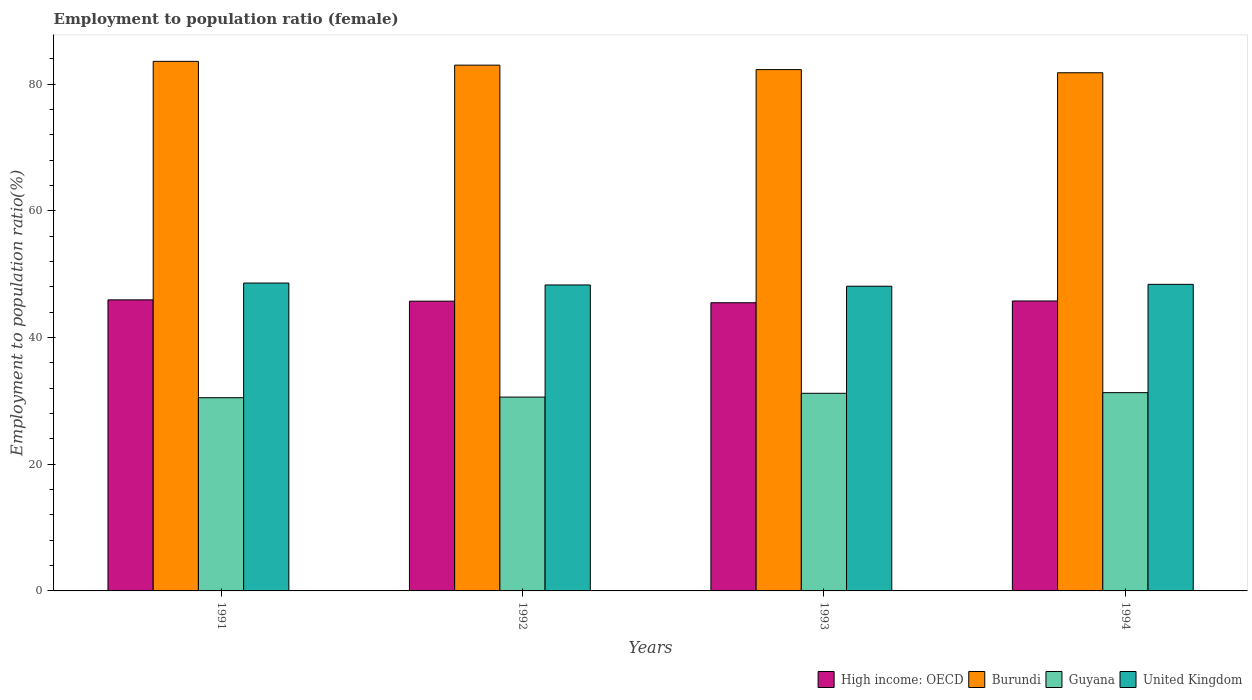How many different coloured bars are there?
Give a very brief answer. 4. Are the number of bars on each tick of the X-axis equal?
Provide a short and direct response. Yes. How many bars are there on the 3rd tick from the right?
Offer a very short reply. 4. What is the label of the 4th group of bars from the left?
Offer a very short reply. 1994. What is the employment to population ratio in High income: OECD in 1994?
Offer a terse response. 45.77. Across all years, what is the maximum employment to population ratio in United Kingdom?
Make the answer very short. 48.6. Across all years, what is the minimum employment to population ratio in Guyana?
Offer a terse response. 30.5. In which year was the employment to population ratio in Guyana minimum?
Offer a terse response. 1991. What is the total employment to population ratio in High income: OECD in the graph?
Make the answer very short. 182.95. What is the difference between the employment to population ratio in United Kingdom in 1993 and that in 1994?
Provide a succinct answer. -0.3. What is the difference between the employment to population ratio in Burundi in 1992 and the employment to population ratio in High income: OECD in 1993?
Offer a terse response. 37.51. What is the average employment to population ratio in Guyana per year?
Your response must be concise. 30.9. In the year 1992, what is the difference between the employment to population ratio in High income: OECD and employment to population ratio in Burundi?
Ensure brevity in your answer.  -37.26. In how many years, is the employment to population ratio in High income: OECD greater than 28 %?
Your response must be concise. 4. What is the ratio of the employment to population ratio in Burundi in 1992 to that in 1994?
Your answer should be compact. 1.01. Is the employment to population ratio in High income: OECD in 1991 less than that in 1993?
Your response must be concise. No. What is the difference between the highest and the second highest employment to population ratio in Burundi?
Offer a terse response. 0.6. What is the difference between the highest and the lowest employment to population ratio in High income: OECD?
Give a very brief answer. 0.45. In how many years, is the employment to population ratio in United Kingdom greater than the average employment to population ratio in United Kingdom taken over all years?
Make the answer very short. 2. What does the 1st bar from the left in 1993 represents?
Your response must be concise. High income: OECD. What does the 4th bar from the right in 1994 represents?
Make the answer very short. High income: OECD. Is it the case that in every year, the sum of the employment to population ratio in United Kingdom and employment to population ratio in Guyana is greater than the employment to population ratio in Burundi?
Make the answer very short. No. Are all the bars in the graph horizontal?
Provide a short and direct response. No. How many years are there in the graph?
Keep it short and to the point. 4. What is the difference between two consecutive major ticks on the Y-axis?
Give a very brief answer. 20. Are the values on the major ticks of Y-axis written in scientific E-notation?
Make the answer very short. No. How are the legend labels stacked?
Your response must be concise. Horizontal. What is the title of the graph?
Ensure brevity in your answer.  Employment to population ratio (female). Does "Papua New Guinea" appear as one of the legend labels in the graph?
Ensure brevity in your answer.  No. What is the label or title of the X-axis?
Ensure brevity in your answer.  Years. What is the Employment to population ratio(%) of High income: OECD in 1991?
Keep it short and to the point. 45.95. What is the Employment to population ratio(%) of Burundi in 1991?
Ensure brevity in your answer.  83.6. What is the Employment to population ratio(%) of Guyana in 1991?
Ensure brevity in your answer.  30.5. What is the Employment to population ratio(%) in United Kingdom in 1991?
Provide a succinct answer. 48.6. What is the Employment to population ratio(%) of High income: OECD in 1992?
Your answer should be compact. 45.74. What is the Employment to population ratio(%) of Burundi in 1992?
Give a very brief answer. 83. What is the Employment to population ratio(%) in Guyana in 1992?
Ensure brevity in your answer.  30.6. What is the Employment to population ratio(%) in United Kingdom in 1992?
Ensure brevity in your answer.  48.3. What is the Employment to population ratio(%) of High income: OECD in 1993?
Provide a short and direct response. 45.49. What is the Employment to population ratio(%) in Burundi in 1993?
Your response must be concise. 82.3. What is the Employment to population ratio(%) of Guyana in 1993?
Keep it short and to the point. 31.2. What is the Employment to population ratio(%) of United Kingdom in 1993?
Ensure brevity in your answer.  48.1. What is the Employment to population ratio(%) of High income: OECD in 1994?
Offer a very short reply. 45.77. What is the Employment to population ratio(%) of Burundi in 1994?
Give a very brief answer. 81.8. What is the Employment to population ratio(%) of Guyana in 1994?
Give a very brief answer. 31.3. What is the Employment to population ratio(%) of United Kingdom in 1994?
Provide a short and direct response. 48.4. Across all years, what is the maximum Employment to population ratio(%) in High income: OECD?
Offer a very short reply. 45.95. Across all years, what is the maximum Employment to population ratio(%) of Burundi?
Ensure brevity in your answer.  83.6. Across all years, what is the maximum Employment to population ratio(%) of Guyana?
Provide a succinct answer. 31.3. Across all years, what is the maximum Employment to population ratio(%) in United Kingdom?
Provide a succinct answer. 48.6. Across all years, what is the minimum Employment to population ratio(%) in High income: OECD?
Make the answer very short. 45.49. Across all years, what is the minimum Employment to population ratio(%) in Burundi?
Offer a very short reply. 81.8. Across all years, what is the minimum Employment to population ratio(%) in Guyana?
Keep it short and to the point. 30.5. Across all years, what is the minimum Employment to population ratio(%) of United Kingdom?
Ensure brevity in your answer.  48.1. What is the total Employment to population ratio(%) in High income: OECD in the graph?
Provide a short and direct response. 182.95. What is the total Employment to population ratio(%) in Burundi in the graph?
Your answer should be compact. 330.7. What is the total Employment to population ratio(%) in Guyana in the graph?
Offer a terse response. 123.6. What is the total Employment to population ratio(%) of United Kingdom in the graph?
Keep it short and to the point. 193.4. What is the difference between the Employment to population ratio(%) of High income: OECD in 1991 and that in 1992?
Ensure brevity in your answer.  0.21. What is the difference between the Employment to population ratio(%) of Guyana in 1991 and that in 1992?
Provide a succinct answer. -0.1. What is the difference between the Employment to population ratio(%) of United Kingdom in 1991 and that in 1992?
Ensure brevity in your answer.  0.3. What is the difference between the Employment to population ratio(%) in High income: OECD in 1991 and that in 1993?
Offer a terse response. 0.45. What is the difference between the Employment to population ratio(%) of Burundi in 1991 and that in 1993?
Provide a succinct answer. 1.3. What is the difference between the Employment to population ratio(%) in Guyana in 1991 and that in 1993?
Give a very brief answer. -0.7. What is the difference between the Employment to population ratio(%) in United Kingdom in 1991 and that in 1993?
Provide a succinct answer. 0.5. What is the difference between the Employment to population ratio(%) in High income: OECD in 1991 and that in 1994?
Offer a terse response. 0.17. What is the difference between the Employment to population ratio(%) in Burundi in 1991 and that in 1994?
Make the answer very short. 1.8. What is the difference between the Employment to population ratio(%) of Guyana in 1991 and that in 1994?
Give a very brief answer. -0.8. What is the difference between the Employment to population ratio(%) of United Kingdom in 1991 and that in 1994?
Give a very brief answer. 0.2. What is the difference between the Employment to population ratio(%) of High income: OECD in 1992 and that in 1993?
Keep it short and to the point. 0.25. What is the difference between the Employment to population ratio(%) in High income: OECD in 1992 and that in 1994?
Ensure brevity in your answer.  -0.03. What is the difference between the Employment to population ratio(%) in Guyana in 1992 and that in 1994?
Provide a succinct answer. -0.7. What is the difference between the Employment to population ratio(%) in High income: OECD in 1993 and that in 1994?
Your response must be concise. -0.28. What is the difference between the Employment to population ratio(%) of United Kingdom in 1993 and that in 1994?
Offer a very short reply. -0.3. What is the difference between the Employment to population ratio(%) of High income: OECD in 1991 and the Employment to population ratio(%) of Burundi in 1992?
Give a very brief answer. -37.05. What is the difference between the Employment to population ratio(%) of High income: OECD in 1991 and the Employment to population ratio(%) of Guyana in 1992?
Provide a short and direct response. 15.35. What is the difference between the Employment to population ratio(%) in High income: OECD in 1991 and the Employment to population ratio(%) in United Kingdom in 1992?
Offer a very short reply. -2.35. What is the difference between the Employment to population ratio(%) of Burundi in 1991 and the Employment to population ratio(%) of United Kingdom in 1992?
Provide a succinct answer. 35.3. What is the difference between the Employment to population ratio(%) in Guyana in 1991 and the Employment to population ratio(%) in United Kingdom in 1992?
Your response must be concise. -17.8. What is the difference between the Employment to population ratio(%) in High income: OECD in 1991 and the Employment to population ratio(%) in Burundi in 1993?
Provide a succinct answer. -36.35. What is the difference between the Employment to population ratio(%) in High income: OECD in 1991 and the Employment to population ratio(%) in Guyana in 1993?
Make the answer very short. 14.75. What is the difference between the Employment to population ratio(%) in High income: OECD in 1991 and the Employment to population ratio(%) in United Kingdom in 1993?
Your answer should be compact. -2.15. What is the difference between the Employment to population ratio(%) in Burundi in 1991 and the Employment to population ratio(%) in Guyana in 1993?
Provide a short and direct response. 52.4. What is the difference between the Employment to population ratio(%) of Burundi in 1991 and the Employment to population ratio(%) of United Kingdom in 1993?
Provide a short and direct response. 35.5. What is the difference between the Employment to population ratio(%) in Guyana in 1991 and the Employment to population ratio(%) in United Kingdom in 1993?
Your response must be concise. -17.6. What is the difference between the Employment to population ratio(%) in High income: OECD in 1991 and the Employment to population ratio(%) in Burundi in 1994?
Keep it short and to the point. -35.85. What is the difference between the Employment to population ratio(%) of High income: OECD in 1991 and the Employment to population ratio(%) of Guyana in 1994?
Keep it short and to the point. 14.65. What is the difference between the Employment to population ratio(%) of High income: OECD in 1991 and the Employment to population ratio(%) of United Kingdom in 1994?
Keep it short and to the point. -2.45. What is the difference between the Employment to population ratio(%) of Burundi in 1991 and the Employment to population ratio(%) of Guyana in 1994?
Your response must be concise. 52.3. What is the difference between the Employment to population ratio(%) of Burundi in 1991 and the Employment to population ratio(%) of United Kingdom in 1994?
Offer a terse response. 35.2. What is the difference between the Employment to population ratio(%) of Guyana in 1991 and the Employment to population ratio(%) of United Kingdom in 1994?
Your response must be concise. -17.9. What is the difference between the Employment to population ratio(%) of High income: OECD in 1992 and the Employment to population ratio(%) of Burundi in 1993?
Ensure brevity in your answer.  -36.56. What is the difference between the Employment to population ratio(%) in High income: OECD in 1992 and the Employment to population ratio(%) in Guyana in 1993?
Your answer should be compact. 14.54. What is the difference between the Employment to population ratio(%) in High income: OECD in 1992 and the Employment to population ratio(%) in United Kingdom in 1993?
Your answer should be very brief. -2.36. What is the difference between the Employment to population ratio(%) in Burundi in 1992 and the Employment to population ratio(%) in Guyana in 1993?
Your answer should be compact. 51.8. What is the difference between the Employment to population ratio(%) of Burundi in 1992 and the Employment to population ratio(%) of United Kingdom in 1993?
Your answer should be compact. 34.9. What is the difference between the Employment to population ratio(%) in Guyana in 1992 and the Employment to population ratio(%) in United Kingdom in 1993?
Offer a very short reply. -17.5. What is the difference between the Employment to population ratio(%) in High income: OECD in 1992 and the Employment to population ratio(%) in Burundi in 1994?
Offer a very short reply. -36.06. What is the difference between the Employment to population ratio(%) of High income: OECD in 1992 and the Employment to population ratio(%) of Guyana in 1994?
Give a very brief answer. 14.44. What is the difference between the Employment to population ratio(%) of High income: OECD in 1992 and the Employment to population ratio(%) of United Kingdom in 1994?
Your response must be concise. -2.66. What is the difference between the Employment to population ratio(%) of Burundi in 1992 and the Employment to population ratio(%) of Guyana in 1994?
Give a very brief answer. 51.7. What is the difference between the Employment to population ratio(%) of Burundi in 1992 and the Employment to population ratio(%) of United Kingdom in 1994?
Keep it short and to the point. 34.6. What is the difference between the Employment to population ratio(%) in Guyana in 1992 and the Employment to population ratio(%) in United Kingdom in 1994?
Offer a very short reply. -17.8. What is the difference between the Employment to population ratio(%) in High income: OECD in 1993 and the Employment to population ratio(%) in Burundi in 1994?
Your response must be concise. -36.31. What is the difference between the Employment to population ratio(%) in High income: OECD in 1993 and the Employment to population ratio(%) in Guyana in 1994?
Offer a very short reply. 14.19. What is the difference between the Employment to population ratio(%) of High income: OECD in 1993 and the Employment to population ratio(%) of United Kingdom in 1994?
Offer a very short reply. -2.91. What is the difference between the Employment to population ratio(%) in Burundi in 1993 and the Employment to population ratio(%) in Guyana in 1994?
Provide a short and direct response. 51. What is the difference between the Employment to population ratio(%) of Burundi in 1993 and the Employment to population ratio(%) of United Kingdom in 1994?
Your response must be concise. 33.9. What is the difference between the Employment to population ratio(%) in Guyana in 1993 and the Employment to population ratio(%) in United Kingdom in 1994?
Your answer should be very brief. -17.2. What is the average Employment to population ratio(%) in High income: OECD per year?
Provide a succinct answer. 45.74. What is the average Employment to population ratio(%) in Burundi per year?
Offer a very short reply. 82.67. What is the average Employment to population ratio(%) in Guyana per year?
Keep it short and to the point. 30.9. What is the average Employment to population ratio(%) of United Kingdom per year?
Your answer should be very brief. 48.35. In the year 1991, what is the difference between the Employment to population ratio(%) of High income: OECD and Employment to population ratio(%) of Burundi?
Ensure brevity in your answer.  -37.65. In the year 1991, what is the difference between the Employment to population ratio(%) in High income: OECD and Employment to population ratio(%) in Guyana?
Offer a terse response. 15.45. In the year 1991, what is the difference between the Employment to population ratio(%) in High income: OECD and Employment to population ratio(%) in United Kingdom?
Your response must be concise. -2.65. In the year 1991, what is the difference between the Employment to population ratio(%) in Burundi and Employment to population ratio(%) in Guyana?
Offer a very short reply. 53.1. In the year 1991, what is the difference between the Employment to population ratio(%) of Guyana and Employment to population ratio(%) of United Kingdom?
Provide a succinct answer. -18.1. In the year 1992, what is the difference between the Employment to population ratio(%) in High income: OECD and Employment to population ratio(%) in Burundi?
Your response must be concise. -37.26. In the year 1992, what is the difference between the Employment to population ratio(%) in High income: OECD and Employment to population ratio(%) in Guyana?
Offer a terse response. 15.14. In the year 1992, what is the difference between the Employment to population ratio(%) of High income: OECD and Employment to population ratio(%) of United Kingdom?
Offer a very short reply. -2.56. In the year 1992, what is the difference between the Employment to population ratio(%) in Burundi and Employment to population ratio(%) in Guyana?
Give a very brief answer. 52.4. In the year 1992, what is the difference between the Employment to population ratio(%) of Burundi and Employment to population ratio(%) of United Kingdom?
Offer a terse response. 34.7. In the year 1992, what is the difference between the Employment to population ratio(%) in Guyana and Employment to population ratio(%) in United Kingdom?
Give a very brief answer. -17.7. In the year 1993, what is the difference between the Employment to population ratio(%) of High income: OECD and Employment to population ratio(%) of Burundi?
Provide a short and direct response. -36.81. In the year 1993, what is the difference between the Employment to population ratio(%) of High income: OECD and Employment to population ratio(%) of Guyana?
Your answer should be very brief. 14.29. In the year 1993, what is the difference between the Employment to population ratio(%) of High income: OECD and Employment to population ratio(%) of United Kingdom?
Provide a succinct answer. -2.61. In the year 1993, what is the difference between the Employment to population ratio(%) in Burundi and Employment to population ratio(%) in Guyana?
Your response must be concise. 51.1. In the year 1993, what is the difference between the Employment to population ratio(%) of Burundi and Employment to population ratio(%) of United Kingdom?
Ensure brevity in your answer.  34.2. In the year 1993, what is the difference between the Employment to population ratio(%) in Guyana and Employment to population ratio(%) in United Kingdom?
Give a very brief answer. -16.9. In the year 1994, what is the difference between the Employment to population ratio(%) of High income: OECD and Employment to population ratio(%) of Burundi?
Keep it short and to the point. -36.03. In the year 1994, what is the difference between the Employment to population ratio(%) in High income: OECD and Employment to population ratio(%) in Guyana?
Make the answer very short. 14.47. In the year 1994, what is the difference between the Employment to population ratio(%) in High income: OECD and Employment to population ratio(%) in United Kingdom?
Offer a very short reply. -2.63. In the year 1994, what is the difference between the Employment to population ratio(%) in Burundi and Employment to population ratio(%) in Guyana?
Provide a short and direct response. 50.5. In the year 1994, what is the difference between the Employment to population ratio(%) of Burundi and Employment to population ratio(%) of United Kingdom?
Offer a very short reply. 33.4. In the year 1994, what is the difference between the Employment to population ratio(%) of Guyana and Employment to population ratio(%) of United Kingdom?
Make the answer very short. -17.1. What is the ratio of the Employment to population ratio(%) in High income: OECD in 1991 to that in 1992?
Provide a short and direct response. 1. What is the ratio of the Employment to population ratio(%) of Burundi in 1991 to that in 1992?
Offer a very short reply. 1.01. What is the ratio of the Employment to population ratio(%) in High income: OECD in 1991 to that in 1993?
Offer a very short reply. 1.01. What is the ratio of the Employment to population ratio(%) in Burundi in 1991 to that in 1993?
Your answer should be very brief. 1.02. What is the ratio of the Employment to population ratio(%) in Guyana in 1991 to that in 1993?
Keep it short and to the point. 0.98. What is the ratio of the Employment to population ratio(%) of United Kingdom in 1991 to that in 1993?
Your response must be concise. 1.01. What is the ratio of the Employment to population ratio(%) of Burundi in 1991 to that in 1994?
Your answer should be very brief. 1.02. What is the ratio of the Employment to population ratio(%) in Guyana in 1991 to that in 1994?
Offer a terse response. 0.97. What is the ratio of the Employment to population ratio(%) of United Kingdom in 1991 to that in 1994?
Keep it short and to the point. 1. What is the ratio of the Employment to population ratio(%) of High income: OECD in 1992 to that in 1993?
Ensure brevity in your answer.  1.01. What is the ratio of the Employment to population ratio(%) of Burundi in 1992 to that in 1993?
Your answer should be very brief. 1.01. What is the ratio of the Employment to population ratio(%) of Guyana in 1992 to that in 1993?
Give a very brief answer. 0.98. What is the ratio of the Employment to population ratio(%) in United Kingdom in 1992 to that in 1993?
Offer a terse response. 1. What is the ratio of the Employment to population ratio(%) in Burundi in 1992 to that in 1994?
Offer a very short reply. 1.01. What is the ratio of the Employment to population ratio(%) of Guyana in 1992 to that in 1994?
Offer a terse response. 0.98. What is the ratio of the Employment to population ratio(%) in United Kingdom in 1992 to that in 1994?
Your answer should be very brief. 1. What is the ratio of the Employment to population ratio(%) of High income: OECD in 1993 to that in 1994?
Your answer should be very brief. 0.99. What is the ratio of the Employment to population ratio(%) of Burundi in 1993 to that in 1994?
Give a very brief answer. 1.01. What is the ratio of the Employment to population ratio(%) in Guyana in 1993 to that in 1994?
Provide a short and direct response. 1. What is the ratio of the Employment to population ratio(%) of United Kingdom in 1993 to that in 1994?
Offer a very short reply. 0.99. What is the difference between the highest and the second highest Employment to population ratio(%) in High income: OECD?
Give a very brief answer. 0.17. What is the difference between the highest and the lowest Employment to population ratio(%) of High income: OECD?
Make the answer very short. 0.45. What is the difference between the highest and the lowest Employment to population ratio(%) of Burundi?
Ensure brevity in your answer.  1.8. 